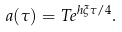Convert formula to latex. <formula><loc_0><loc_0><loc_500><loc_500>a ( \tau ) = T e ^ { h \xi \tau / 4 } .</formula> 